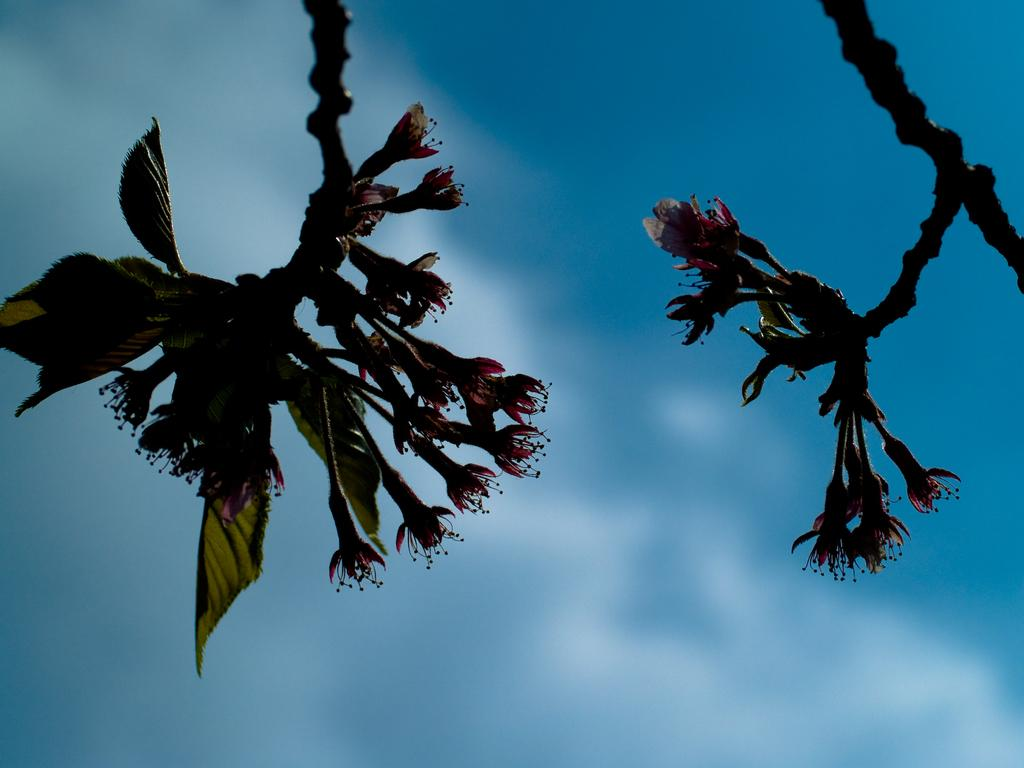What is present in the image that belongs to a tree? There are branches of a tree in the image. What can be observed on the tree branches? The tree branches have flowers and leaves. What can be seen in the background of the image? The sky is visible in the background of the image. How many goldfish are swimming in the tree branches in the image? There are no goldfish present in the image; it features tree branches with flowers and leaves. What type of pets are visible in the image? There are no pets visible in the image; it features tree branches with flowers and leaves. 